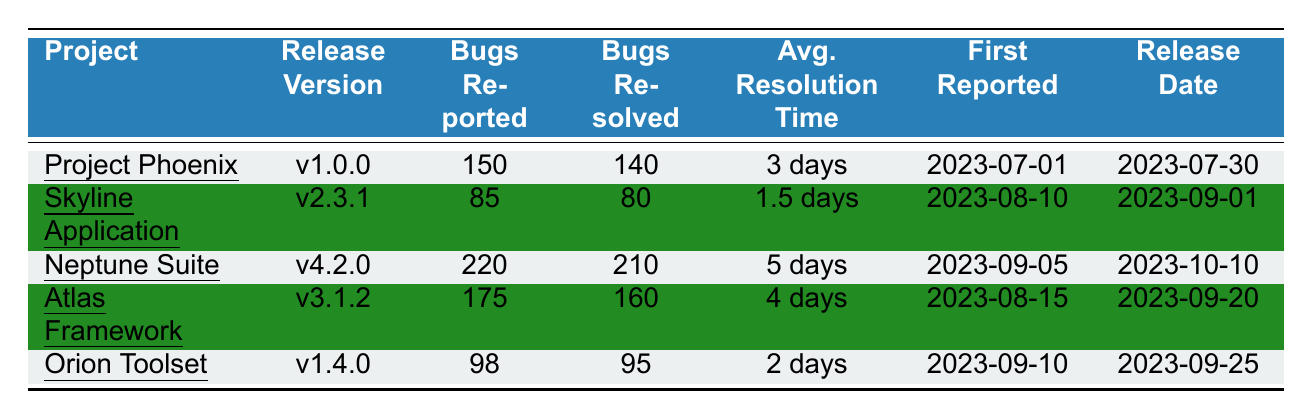What is the total number of bugs reported for the Orion Toolset? The table lists the total number of bugs reported for Orion Toolset as 98.
Answer: 98 Which project has the longest average resolution time? Looking at the "Average Resolution Time" column, Neptune Suite has the longest average resolution time of 5 days.
Answer: Neptune Suite How many bugs were resolved for Project Phoenix? The table shows that for Project Phoenix, a total of 140 bugs were resolved.
Answer: 140 What is the average resolution time across all projects? The average resolution times are 3 days for Project Phoenix, 1.5 days for Skyline Application, 5 days for Neptune Suite, 4 days for Atlas Framework, and 2 days for Orion Toolset. The sum is (3 + 1.5 + 5 + 4 + 2) = 15. Dividing by 5 gives an average of 15/5 = 3 days.
Answer: 3 days Has the Atlas Framework resolved more bugs than it reported? The table indicates that the Atlas Framework reported 175 bugs and resolved 160. Since 160 is less than 175, it has not resolved more bugs than it reported.
Answer: No Which release had the first bugs reported? The First Reported date for Project Phoenix is 2023-07-01, which is earlier than the others.
Answer: Project Phoenix If we consider the top 3 projects by total bugs reported, what is their combined average resolution time? The top 3 projects are Neptune Suite (5 days), Atlas Framework (4 days), and Project Phoenix (3 days). Their combined total resolution time is (5 + 4 + 3) = 12 days, and dividing by 3 gives an average of 12/3 = 4 days.
Answer: 4 days How many bugs were not resolved for the Skyline Application? The Skyline Application reported 85 bugs and resolved 80. Subtracting the resolved from reported gives 85 - 80 = 5 bugs not resolved.
Answer: 5 Did any project resolve all the bugs it reported? No project completely resolved all bugs as each has some unresolved bugs: Project Phoenix (10 unresolved), Skyline Application (5 unresolved), Neptune Suite (10 unresolved), Atlas Framework (15 unresolved), and Orion Toolset (3 unresolved).
Answer: No What project had the most bugs reported? By comparing the "Total Bugs Reported" values, Neptune Suite has the highest number of reported bugs at 220.
Answer: Neptune Suite 